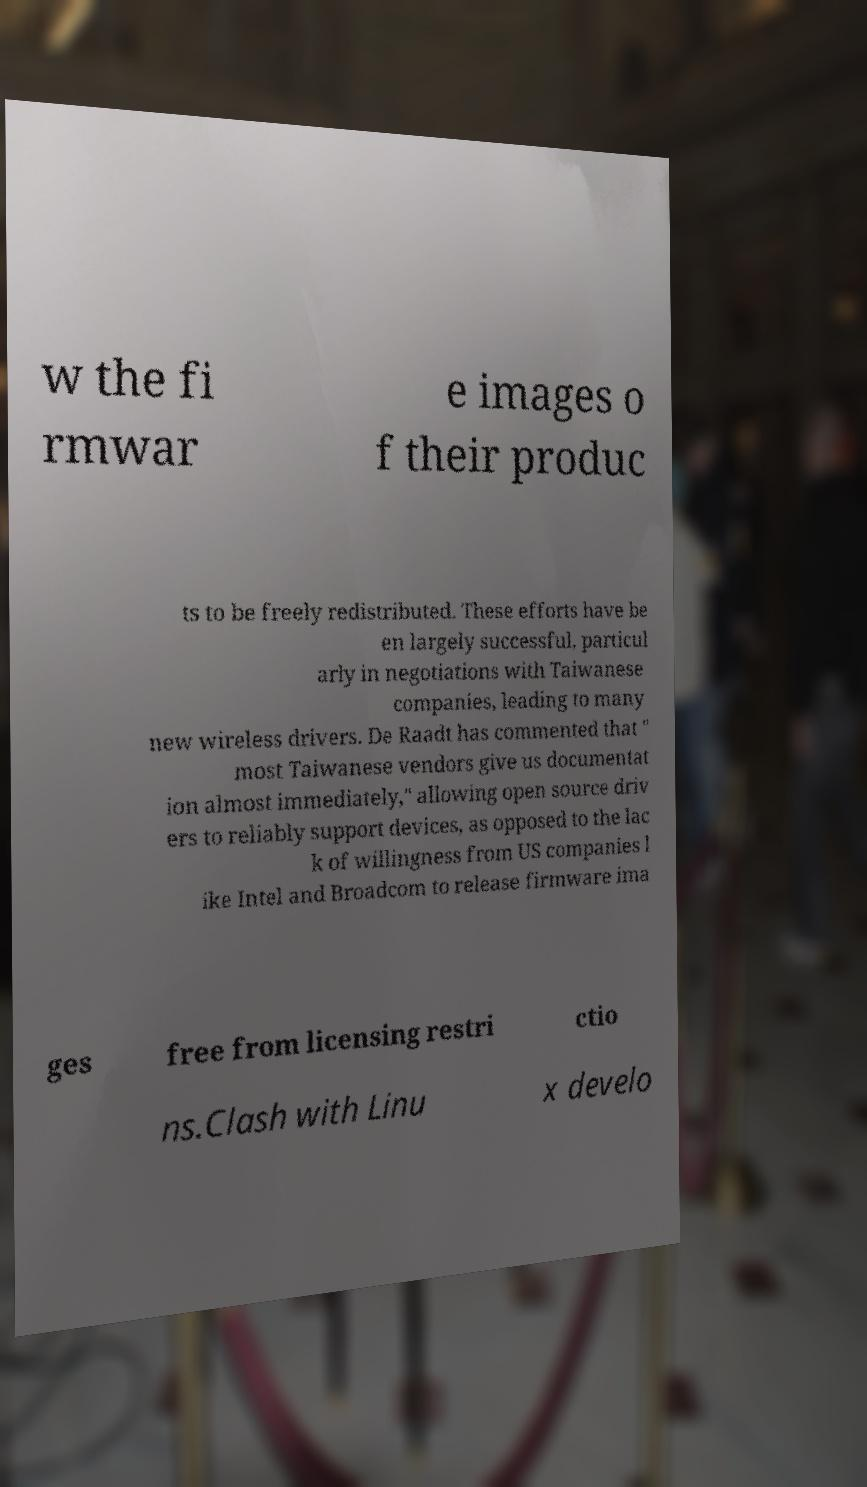Could you extract and type out the text from this image? w the fi rmwar e images o f their produc ts to be freely redistributed. These efforts have be en largely successful, particul arly in negotiations with Taiwanese companies, leading to many new wireless drivers. De Raadt has commented that " most Taiwanese vendors give us documentat ion almost immediately," allowing open source driv ers to reliably support devices, as opposed to the lac k of willingness from US companies l ike Intel and Broadcom to release firmware ima ges free from licensing restri ctio ns.Clash with Linu x develo 